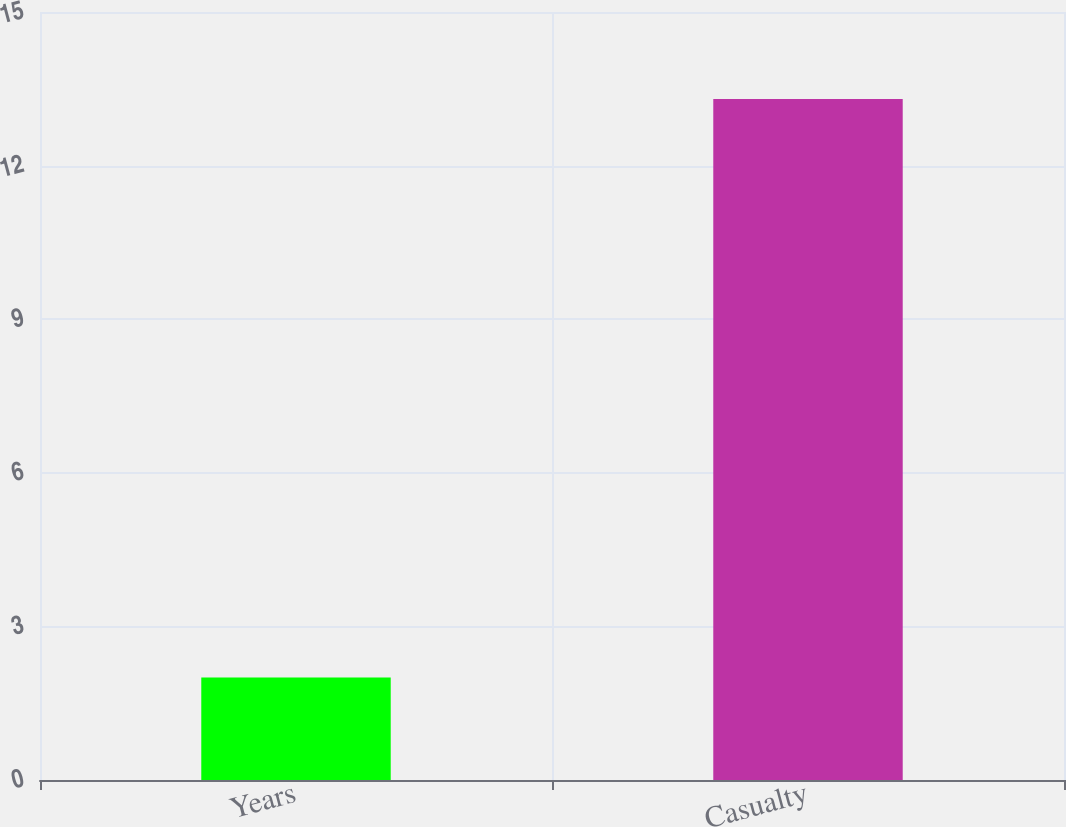<chart> <loc_0><loc_0><loc_500><loc_500><bar_chart><fcel>Years<fcel>Casualty<nl><fcel>2<fcel>13.3<nl></chart> 